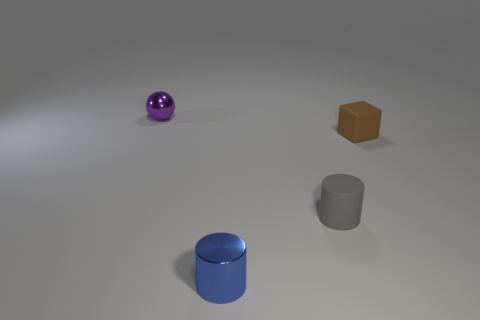Is there any other thing that is the same size as the metallic cylinder?
Offer a terse response. Yes. How many other things are there of the same color as the rubber block?
Ensure brevity in your answer.  0. What number of blocks are either purple things or blue things?
Offer a very short reply. 0. There is a cylinder that is behind the small shiny thing that is in front of the tiny purple thing; what is its color?
Your response must be concise. Gray. What is the shape of the tiny blue thing?
Offer a terse response. Cylinder. Is the size of the purple sphere left of the brown matte thing the same as the blue cylinder?
Offer a very short reply. Yes. Are there any tiny blocks that have the same material as the small brown object?
Make the answer very short. No. What number of things are either tiny metallic objects that are behind the gray rubber cylinder or purple things?
Provide a short and direct response. 1. Are there any tiny blocks?
Your answer should be very brief. Yes. The object that is both in front of the small brown matte cube and behind the tiny blue metallic cylinder has what shape?
Make the answer very short. Cylinder. 